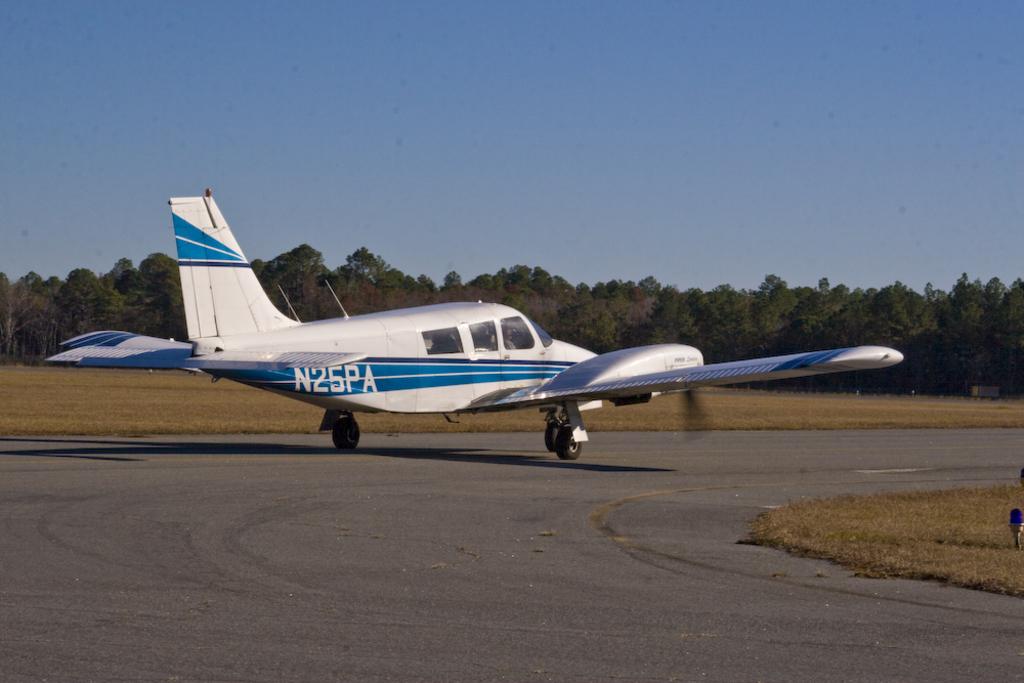What is the numbers and letters printed near the rear of the plane?
Your response must be concise. N25pa. 